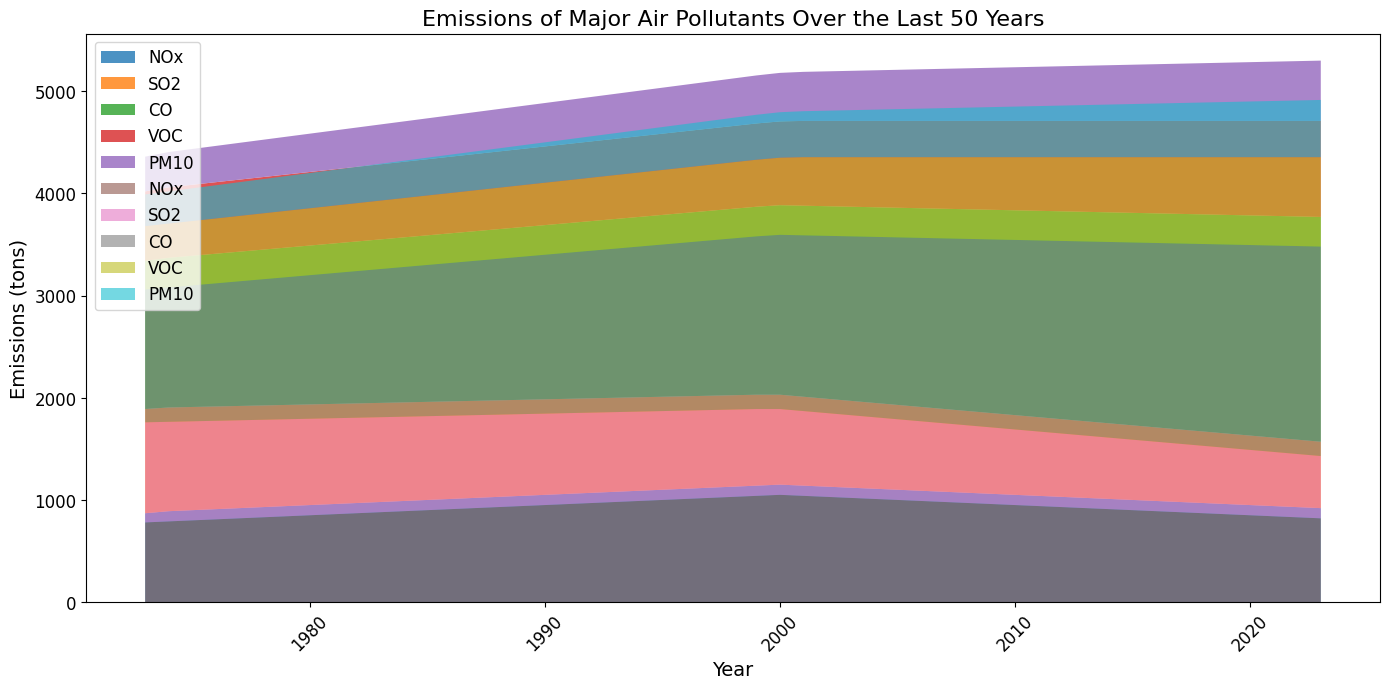How many tons of CO emissions were there in Region A in the year 2000? Look at the year 2000 for Region A and find the value for CO emissions.
Answer: 1855 Which pollutant showed the most significant relative decrease in Region B from 1973 to 2023? Compare the values for all pollutants in Region B between 1973 and 2023 to see which had the largest proportional reduction.
Answer: SO2 Between 1990 and 2000, did PM10 emissions increase or decrease in Region A? Compare the PM10 values for Region A between years 1990 and 2000.
Answer: Increase What was the combined total of NOx and VOC emissions in Region A in 1985? Sum the emissions of NOx and VOC for Region A in 1985.
Answer: 1745 By how many tons did CO emissions change in Region B between 2010 and 2020? Subtract CO emissions in Region B for 2010 from those in 2020.
Answer: 150 In which year did Region A's SO2 emissions first fall below 900 tons? Find the year when SO2 emissions in Region A dropped below 900 tons for the first time.
Answer: 2001 Compare the visual height of PM10 in Region A and Region B in 2023: which one is taller and by how much? Assess the height representation of PM10 for both regions in 2023 and subtract the shorter height from the taller height.
Answer: Region A by 30 Has the top contributor to total emissions in Region B been constant over the years? If not, what has changed? Observe the pollutant contributions over the years in Region B to see if the highest contributor has changed.
Answer: No, CO overtook NOx 